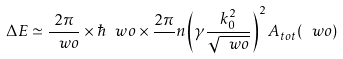<formula> <loc_0><loc_0><loc_500><loc_500>\Delta E \simeq \frac { 2 \pi } { \ w o } \times \hbar { \ } w o \times \frac { 2 \pi } { } n \left ( \gamma \frac { k _ { 0 } ^ { 2 } } { \sqrt { \ w o } } \right ) ^ { 2 } A _ { t o t } ( \ w o )</formula> 